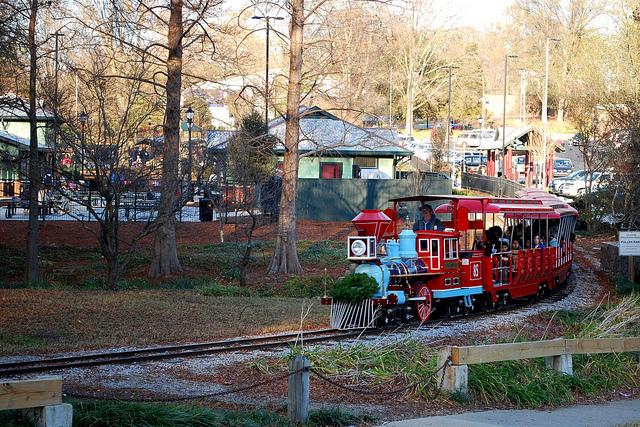Is this a normal size train?
Be succinct. No. How is the weather?
Answer briefly. Sunny. What color is the train?
Short answer required. Red. Is it daytime?
Write a very short answer. Yes. What kind of fence is in the picture?
Concise answer only. Wooden. 